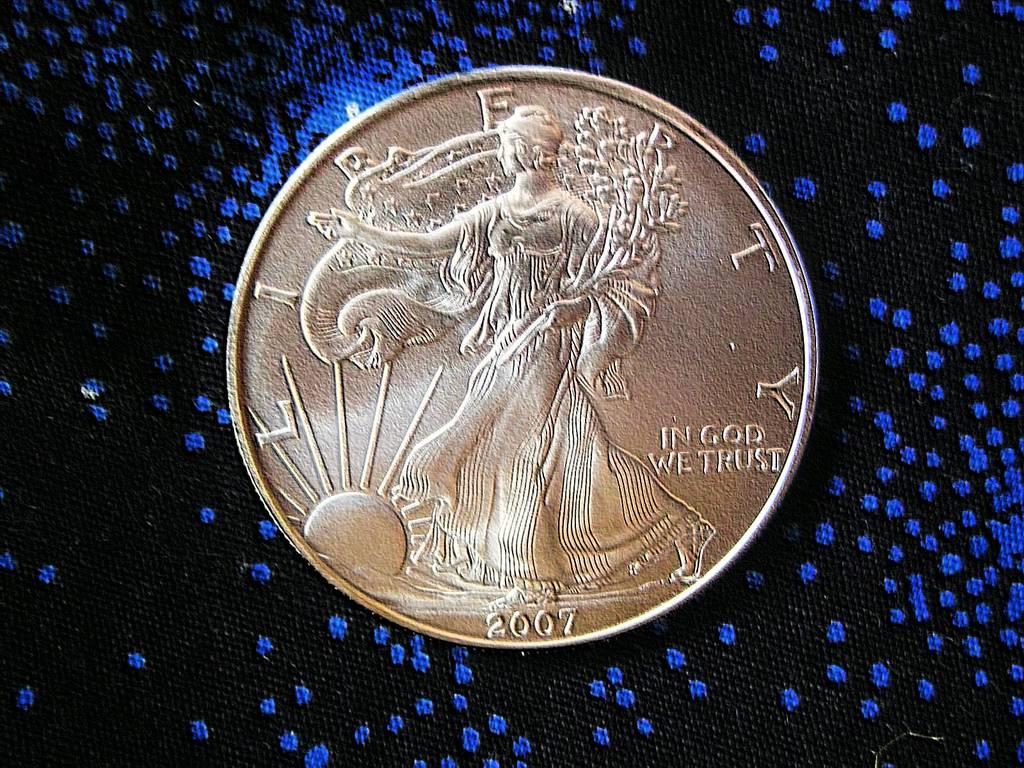What date is the coin?
Your answer should be compact. 2007. What does it say on the top portion of the coin?
Provide a short and direct response. Liberty. 